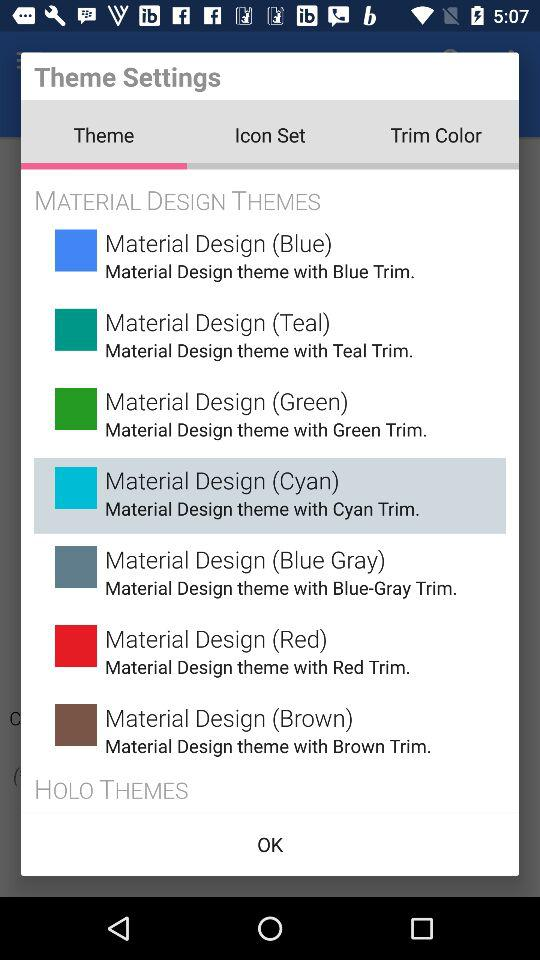What are the different material design themes? The different themes are "Material Design (Blue)", "Material Design (Teal)", "Material Design (Green)", "Material Design (Cyan)", "Material Design (Blue Gray)", "Material Design (Red)" and "Material Design (Brown)". 